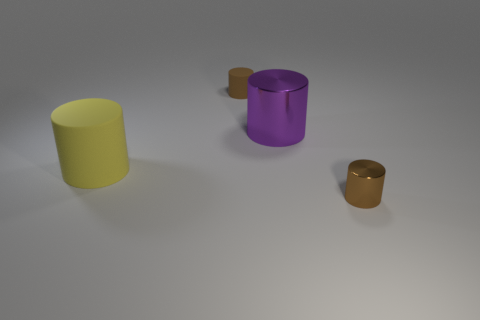Is the color of the tiny matte thing the same as the small metallic cylinder?
Make the answer very short. Yes. Is the number of purple shiny objects that are in front of the purple cylinder the same as the number of small matte objects to the left of the small metallic cylinder?
Offer a terse response. No. How many yellow objects are big rubber cylinders or tiny matte things?
Your response must be concise. 1. How many small brown things are the same shape as the yellow matte object?
Provide a short and direct response. 2. What material is the yellow cylinder?
Offer a very short reply. Rubber. Are there the same number of large cylinders left of the small brown matte object and big purple metal blocks?
Keep it short and to the point. No. What shape is the brown matte object that is the same size as the brown metallic cylinder?
Offer a terse response. Cylinder. There is a large yellow object that is in front of the purple cylinder; is there a tiny brown cylinder behind it?
Offer a terse response. Yes. What number of large objects are either brown shiny things or green objects?
Offer a very short reply. 0. Is there a red block that has the same size as the brown metallic cylinder?
Your answer should be very brief. No. 